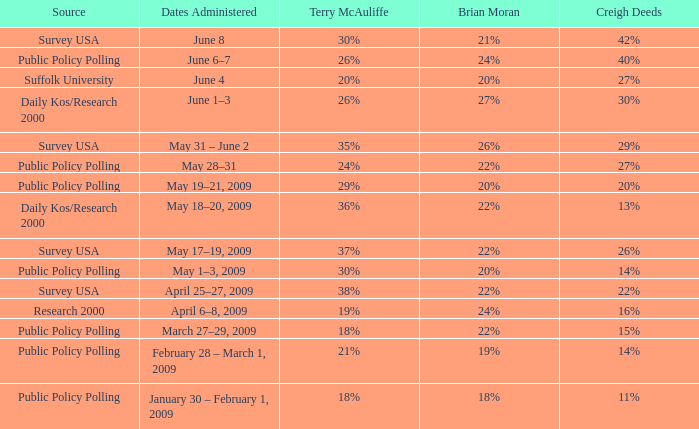What is the percentage of Terry McAuliffe that has a Date Administered on May 31 – june 2 35%. 